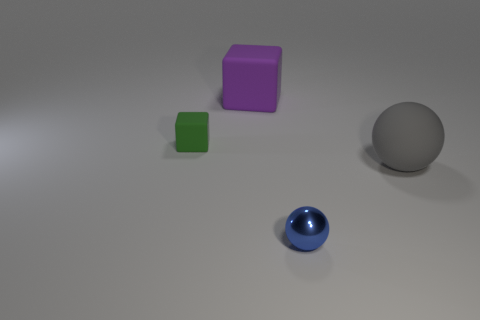Add 2 large brown matte cylinders. How many objects exist? 6 Subtract all small things. Subtract all small purple rubber things. How many objects are left? 2 Add 2 spheres. How many spheres are left? 4 Add 3 big gray things. How many big gray things exist? 4 Subtract 0 brown cubes. How many objects are left? 4 